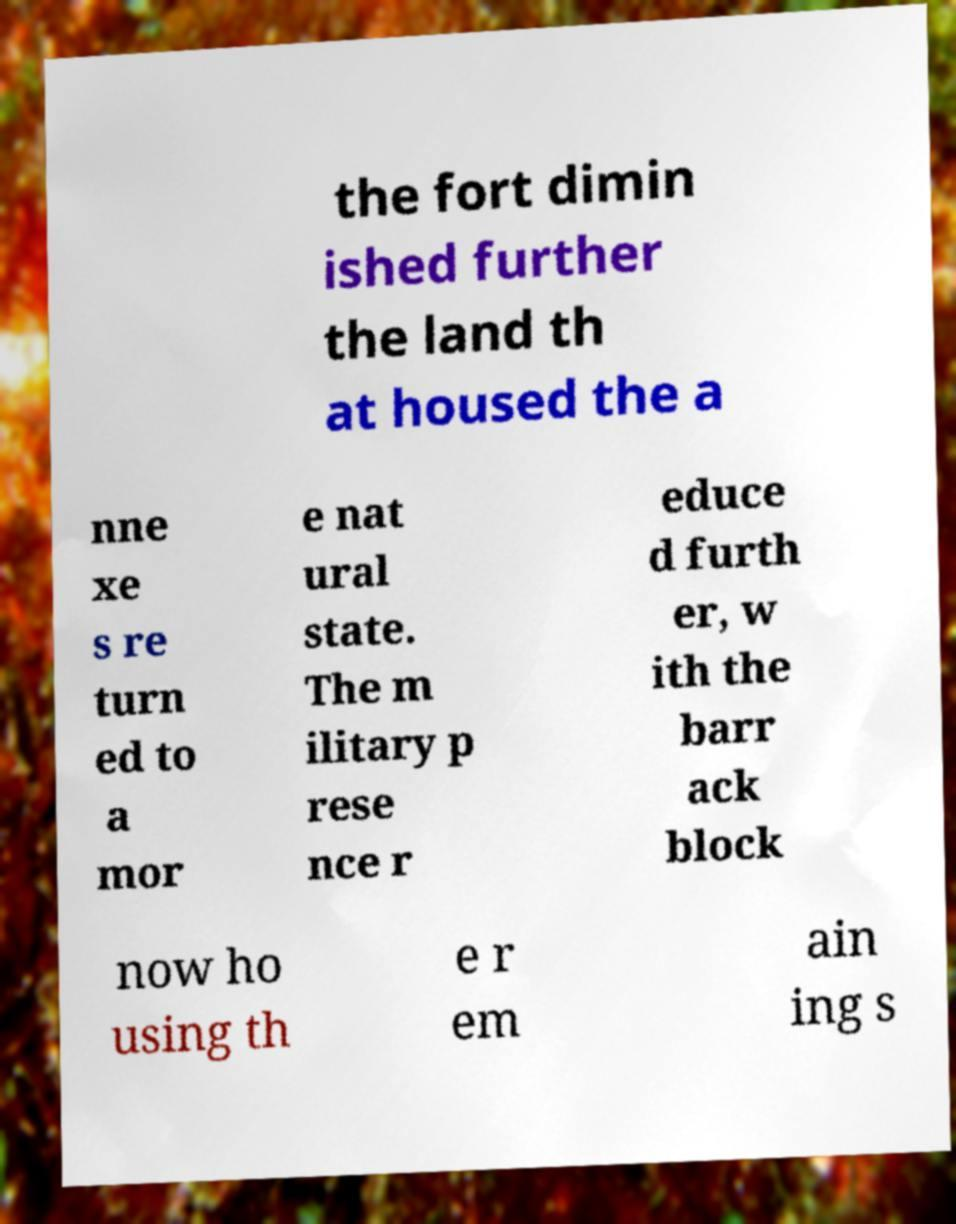Could you assist in decoding the text presented in this image and type it out clearly? the fort dimin ished further the land th at housed the a nne xe s re turn ed to a mor e nat ural state. The m ilitary p rese nce r educe d furth er, w ith the barr ack block now ho using th e r em ain ing s 